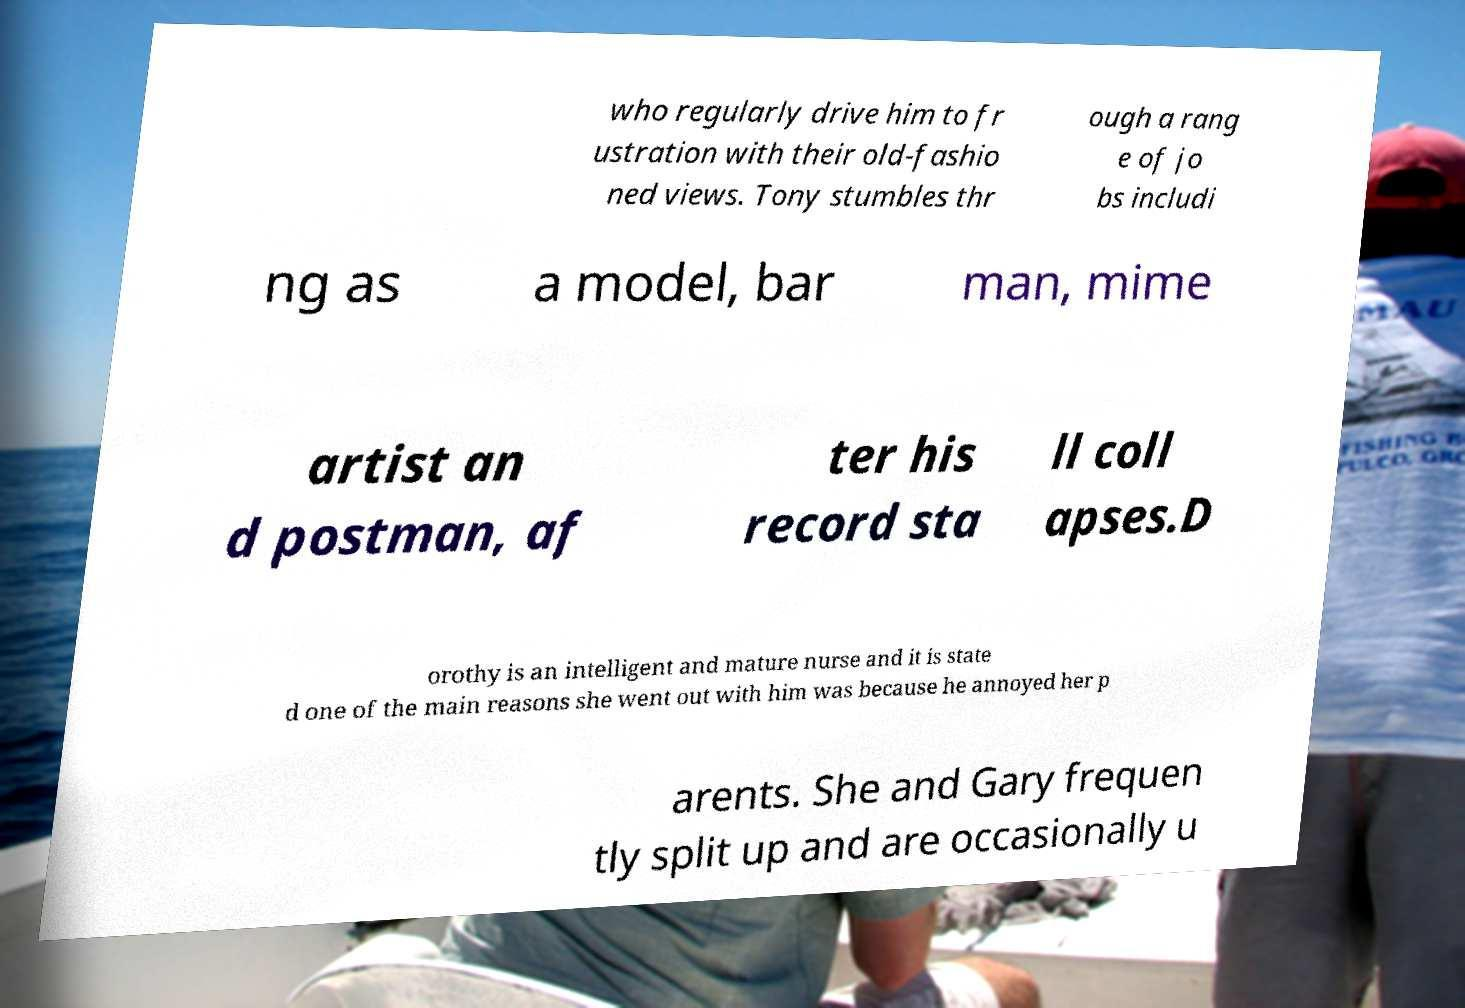There's text embedded in this image that I need extracted. Can you transcribe it verbatim? who regularly drive him to fr ustration with their old-fashio ned views. Tony stumbles thr ough a rang e of jo bs includi ng as a model, bar man, mime artist an d postman, af ter his record sta ll coll apses.D orothy is an intelligent and mature nurse and it is state d one of the main reasons she went out with him was because he annoyed her p arents. She and Gary frequen tly split up and are occasionally u 